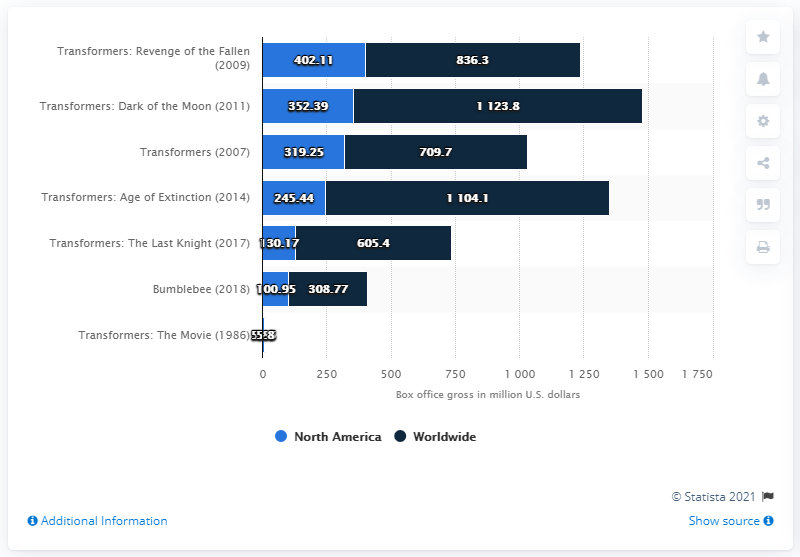Identify some key points in this picture. Transformers: Age of Extinction grossed a total of 245.44 million dollars at the box office. 